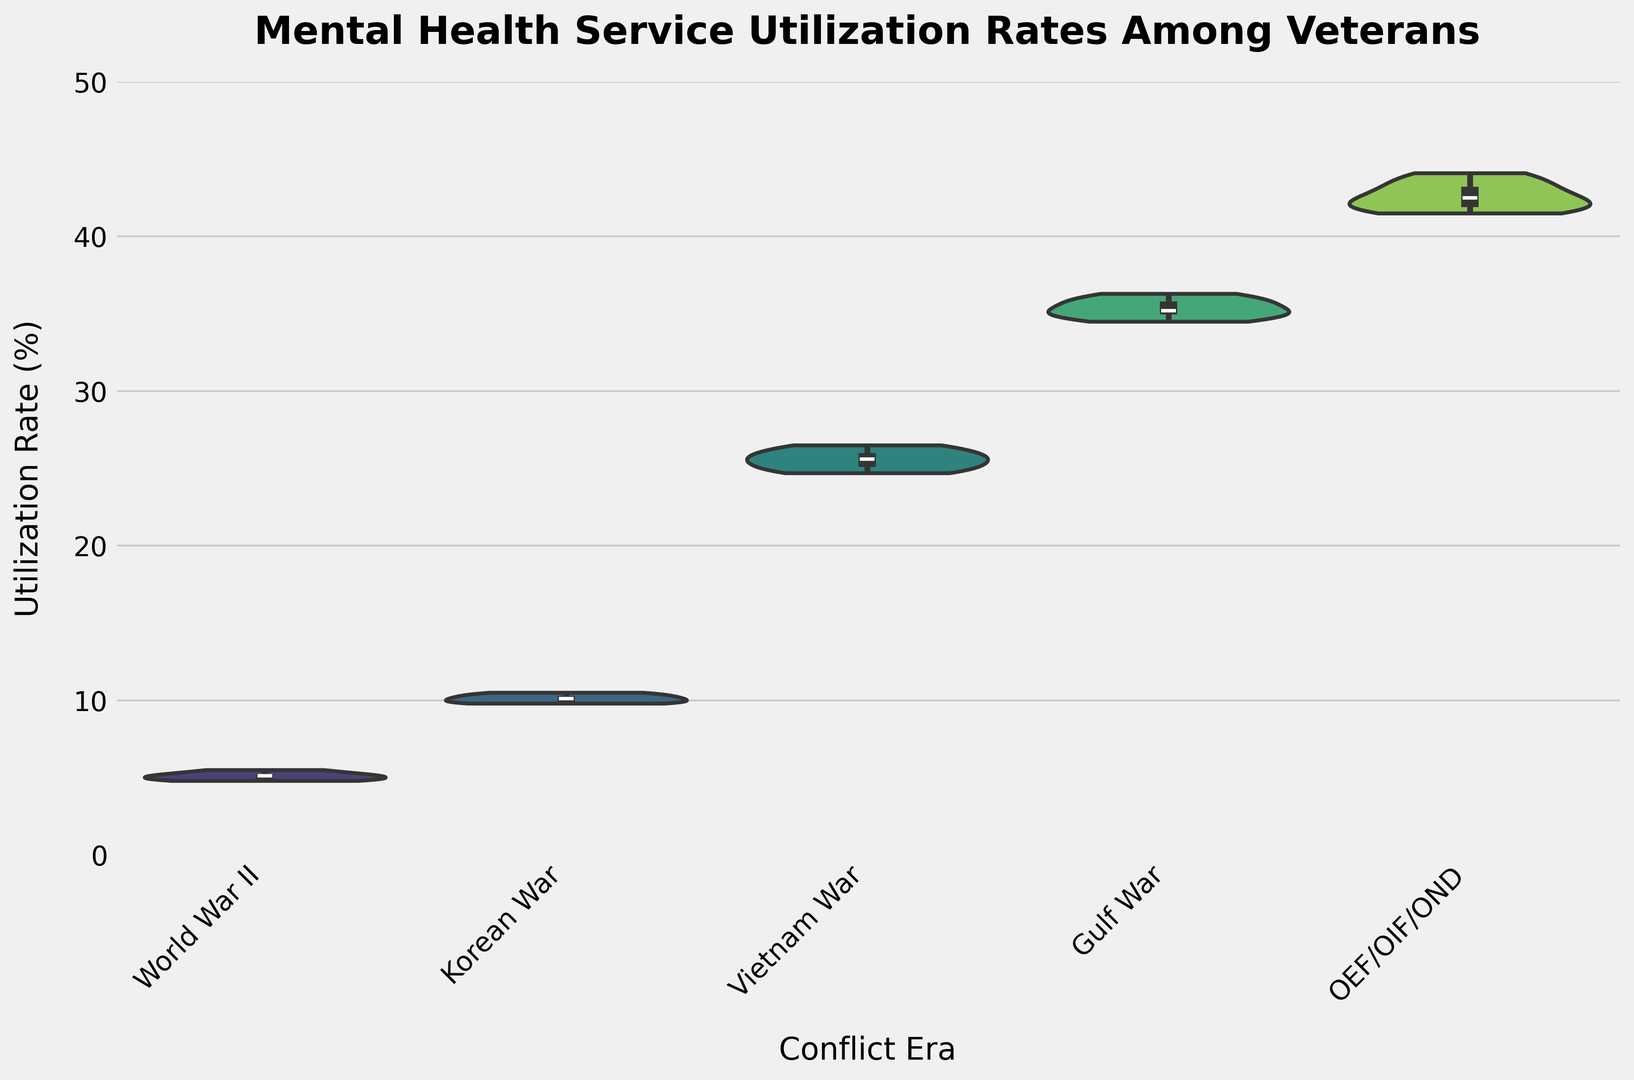Which conflict era has the highest median utilization rate? To find the median utilization rate for each conflict era, one must locate the middle value of the plotted distributions in the violin plot. The OEF/OIF/OND era shows the highest median value among all the listed conflict eras.
Answer: OEF/OIF/OND Which group has the widest distribution of utilization rates? Observing the width of the violin shapes, which represent the distribution spread, the OEF/OIF/OND group shows the widest spread, indicating a larger distribution of utilization rates.
Answer: OEF/OIF/OND How does the utilization rate of the Vietnam War era compare to the Korean War era? To compare the utilization rates, look at the violin plots for both eras. The Vietnam War era has a higher median utilization rate compared to the Korean War era.
Answer: Vietnam War > Korean War Which era has the smallest interquartile range (IQR) for utilization rates? The IQR is seen in the box inside the violin plot. Compare the sizes of the boxes for each era. The World War II era has the smallest box, indicating the smallest IQR.
Answer: World War II Compare the skewness of the utilization rates for the Vietnam War and OEF/OIF/OND eras. Visualize the symmetry of the distributions. The Vietnam War era appears more symmetrical, whereas the OEF/OIF/OND era shows a right-skew.
Answer: Vietnam War: symmetric, OEF/OIF/OND: right-skew 